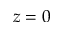Convert formula to latex. <formula><loc_0><loc_0><loc_500><loc_500>z = 0</formula> 